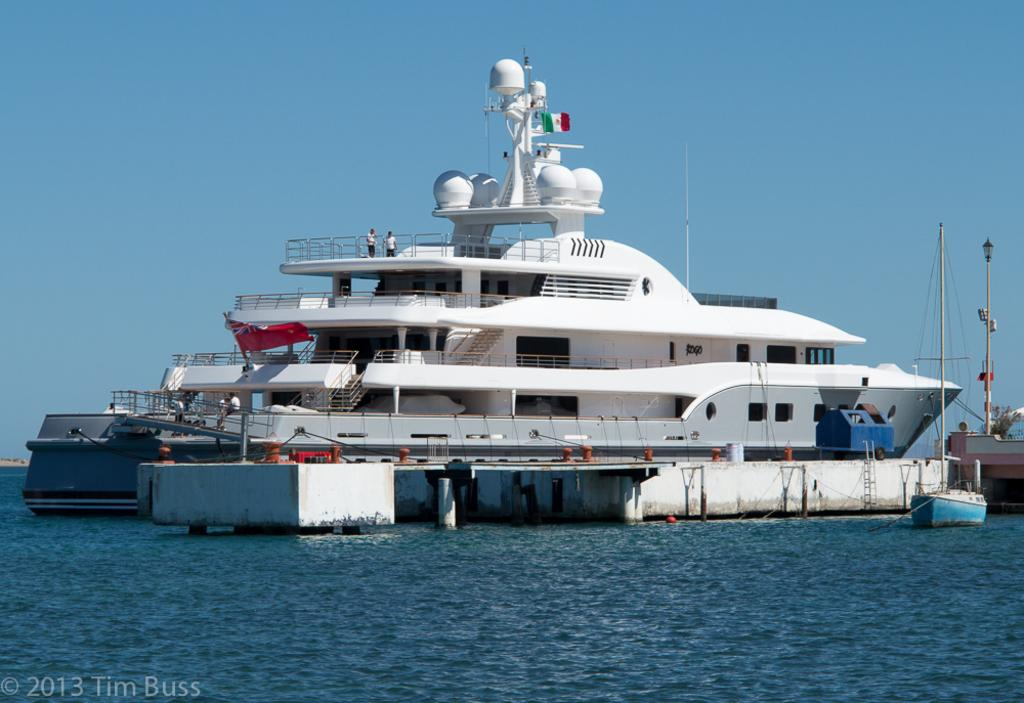What is the main subject of the image? The main subject of the image is a cruise. Where is the cruise located? The cruise is on the water. Can you describe the person in the image? There is a person standing on the cruise. What can be seen in the background of the image? The sky is visible in the background of the image. What type of collar can be seen on the cheese in the image? There is no cheese or collar present in the image; it features a cruise on the water with a person standing on it and a visible sky in the background. 